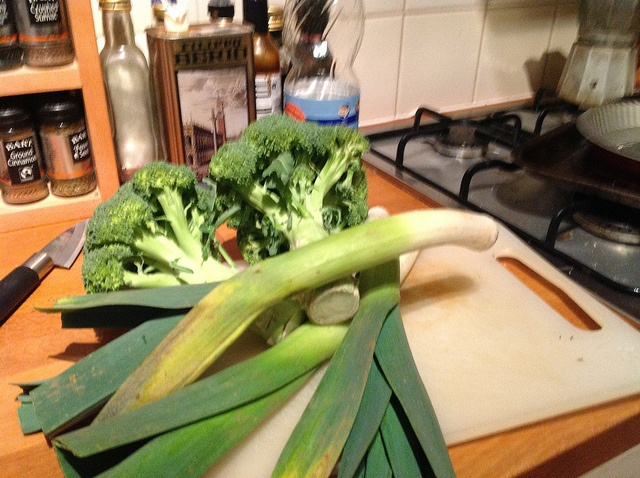Describe the objects in this image and their specific colors. I can see broccoli in gray, olive, khaki, darkgreen, and black tones, oven in gray and black tones, bottle in gray, tan, black, and lightgray tones, bottle in gray, tan, and maroon tones, and bottle in gray, black, maroon, brown, and tan tones in this image. 